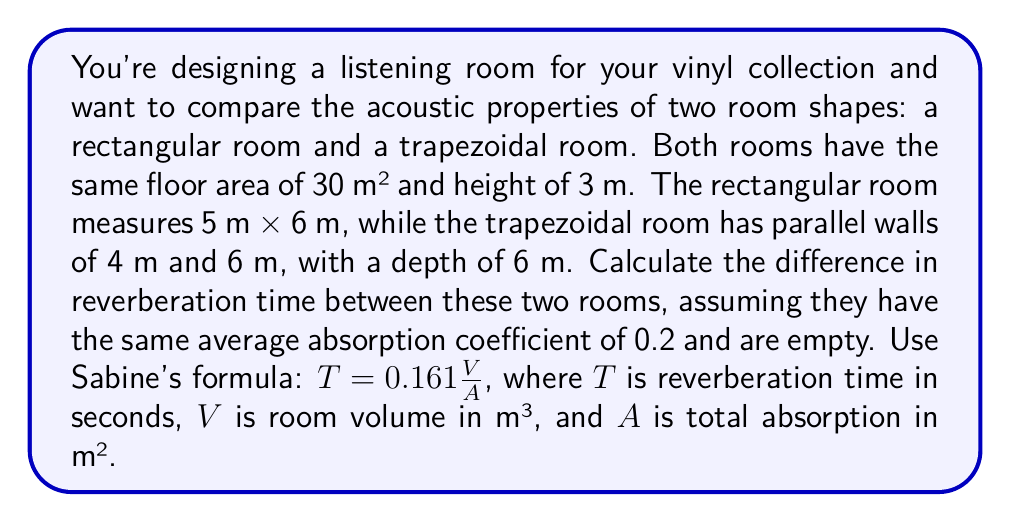Show me your answer to this math problem. Let's approach this step-by-step:

1) First, calculate the volumes of both rooms:
   
   Rectangular room: $V_r = 5 \times 6 \times 3 = 90$ m³
   Trapezoidal room: $V_t = \frac{(4+6)}{2} \times 6 \times 3 = 90$ m³

2) Calculate the surface areas of each room:
   
   Rectangular room: 
   $S_r = 2(5 \times 6 + 5 \times 3 + 6 \times 3) = 126$ m²

   Trapezoidal room:
   Floor and ceiling: $2 \times 30 = 60$ m²
   Parallel walls: $2 \times 3 \times (4 + 6) = 60$ m²
   Slanted walls: $2 \times 3 \times 6 = 36$ m²
   Total: $S_t = 60 + 60 + 36 = 156$ m²

3) Calculate total absorption for each room:
   
   $A_r = 0.2 \times 126 = 25.2$ m²
   $A_t = 0.2 \times 156 = 31.2$ m²

4) Apply Sabine's formula for each room:
   
   $T_r = 0.161 \frac{90}{25.2} = 0.575$ s
   $T_t = 0.161 \frac{90}{31.2} = 0.464$ s

5) Calculate the difference in reverberation time:
   
   $\Delta T = T_r - T_t = 0.575 - 0.464 = 0.111$ s
Answer: 0.111 s 